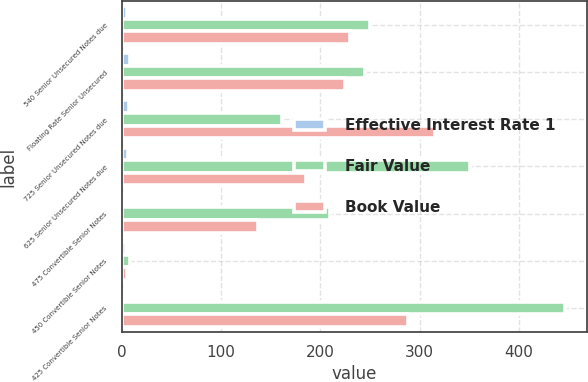<chart> <loc_0><loc_0><loc_500><loc_500><stacked_bar_chart><ecel><fcel>540 Senior Unsecured Notes due<fcel>Floating Rate Senior Unsecured<fcel>725 Senior Unsecured Notes due<fcel>625 Senior Unsecured Notes due<fcel>475 Convertible Senior Notes<fcel>450 Convertible Senior Notes<fcel>425 Convertible Senior Notes<nl><fcel>Effective Interest Rate 1<fcel>5.43<fcel>8.65<fcel>7.25<fcel>6.29<fcel>3.5<fcel>4.5<fcel>0.58<nl><fcel>Fair Value<fcel>249.9<fcel>245.1<fcel>161.45<fcel>350.2<fcel>209.5<fcel>8.7<fcel>446.3<nl><fcel>Book Value<fcel>230<fcel>225<fcel>315<fcel>185.5<fcel>137.4<fcel>5.7<fcel>288<nl></chart> 